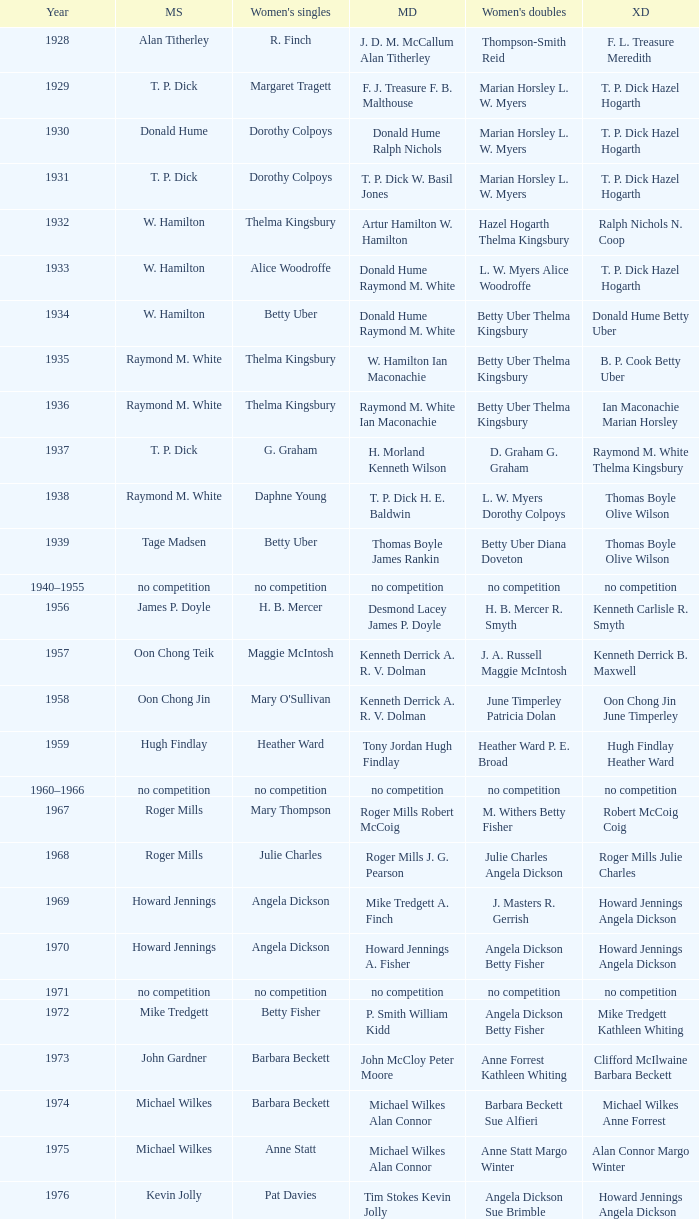Who won the Women's doubles in the year that David Eddy Eddy Sutton won the Men's doubles, and that David Eddy won the Men's singles? Anne Statt Jane Webster. 